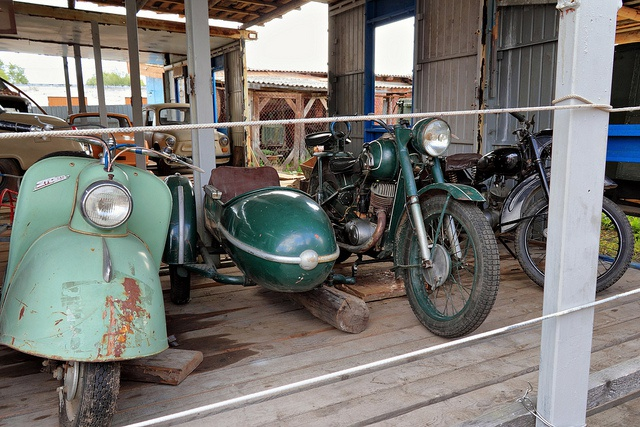Describe the objects in this image and their specific colors. I can see motorcycle in black, darkgray, teal, gray, and lightblue tones, motorcycle in black, gray, darkgray, and teal tones, motorcycle in black, gray, and darkgray tones, truck in black, gray, and lightgray tones, and car in black, gray, and maroon tones in this image. 